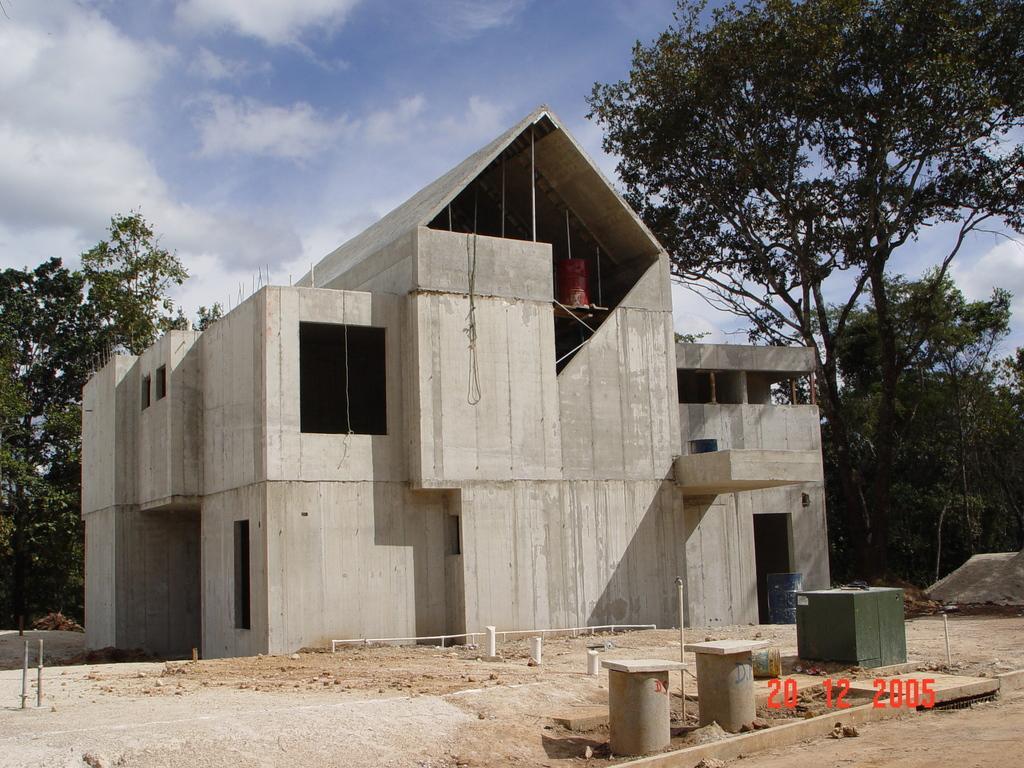Describe this image in one or two sentences. There are cement structures and a watermark is present at the bottom of this image. We can see a building and trees in the middle of this image and the sky is in the background. 